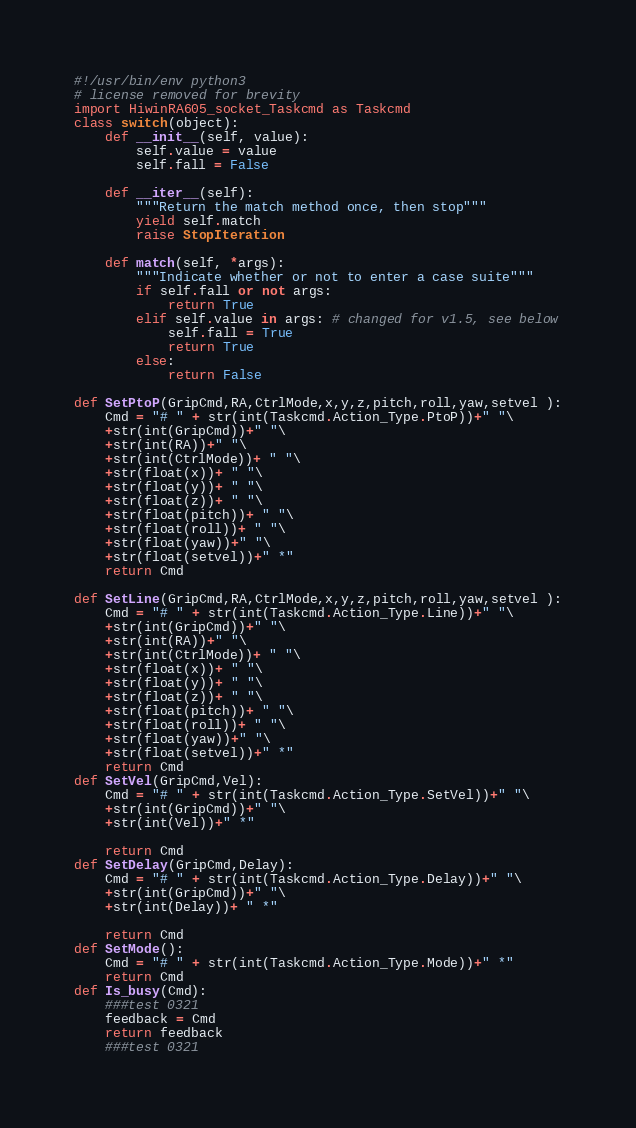<code> <loc_0><loc_0><loc_500><loc_500><_Python_>#!/usr/bin/env python3
# license removed for brevity
import HiwinRA605_socket_Taskcmd as Taskcmd
class switch(object):
    def __init__(self, value):
        self.value = value
        self.fall = False

    def __iter__(self):
        """Return the match method once, then stop"""
        yield self.match
        raise StopIteration

    def match(self, *args):
        """Indicate whether or not to enter a case suite"""
        if self.fall or not args:
            return True
        elif self.value in args: # changed for v1.5, see below
            self.fall = True
            return True
        else:
            return False

def SetPtoP(GripCmd,RA,CtrlMode,x,y,z,pitch,roll,yaw,setvel ):
    Cmd = "# " + str(int(Taskcmd.Action_Type.PtoP))+" "\
    +str(int(GripCmd))+" "\
    +str(int(RA))+" "\
    +str(int(CtrlMode))+ " "\
    +str(float(x))+ " "\
    +str(float(y))+ " "\
    +str(float(z))+ " "\
    +str(float(pitch))+ " "\
    +str(float(roll))+ " "\
    +str(float(yaw))+" "\
    +str(float(setvel))+" *"
    return Cmd

def SetLine(GripCmd,RA,CtrlMode,x,y,z,pitch,roll,yaw,setvel ):
    Cmd = "# " + str(int(Taskcmd.Action_Type.Line))+" "\
    +str(int(GripCmd))+" "\
    +str(int(RA))+" "\
    +str(int(CtrlMode))+ " "\
    +str(float(x))+ " "\
    +str(float(y))+ " "\
    +str(float(z))+ " "\
    +str(float(pitch))+ " "\
    +str(float(roll))+ " "\
    +str(float(yaw))+" "\
    +str(float(setvel))+" *"
    return Cmd
def SetVel(GripCmd,Vel):
    Cmd = "# " + str(int(Taskcmd.Action_Type.SetVel))+" "\
    +str(int(GripCmd))+" "\
    +str(int(Vel))+" *"

    return Cmd
def SetDelay(GripCmd,Delay):
    Cmd = "# " + str(int(Taskcmd.Action_Type.Delay))+" "\
    +str(int(GripCmd))+" "\
    +str(int(Delay))+ " *"

    return Cmd
def SetMode():
    Cmd = "# " + str(int(Taskcmd.Action_Type.Mode))+" *"
    return Cmd
def Is_busy(Cmd):
    ###test 0321
    feedback = Cmd
    return feedback
    ###test 0321</code> 